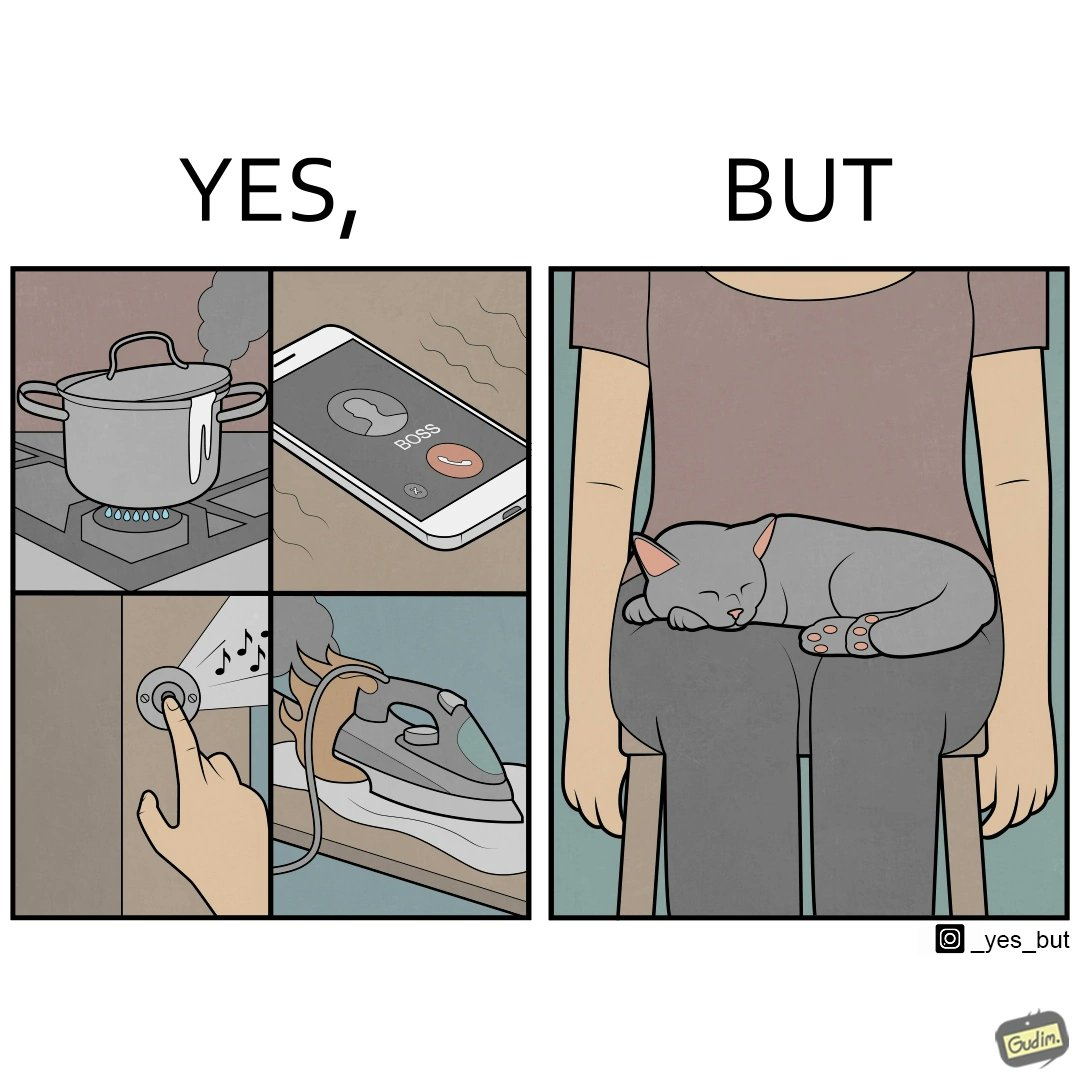Is this image satirical or non-satirical? Yes, this image is satirical. 